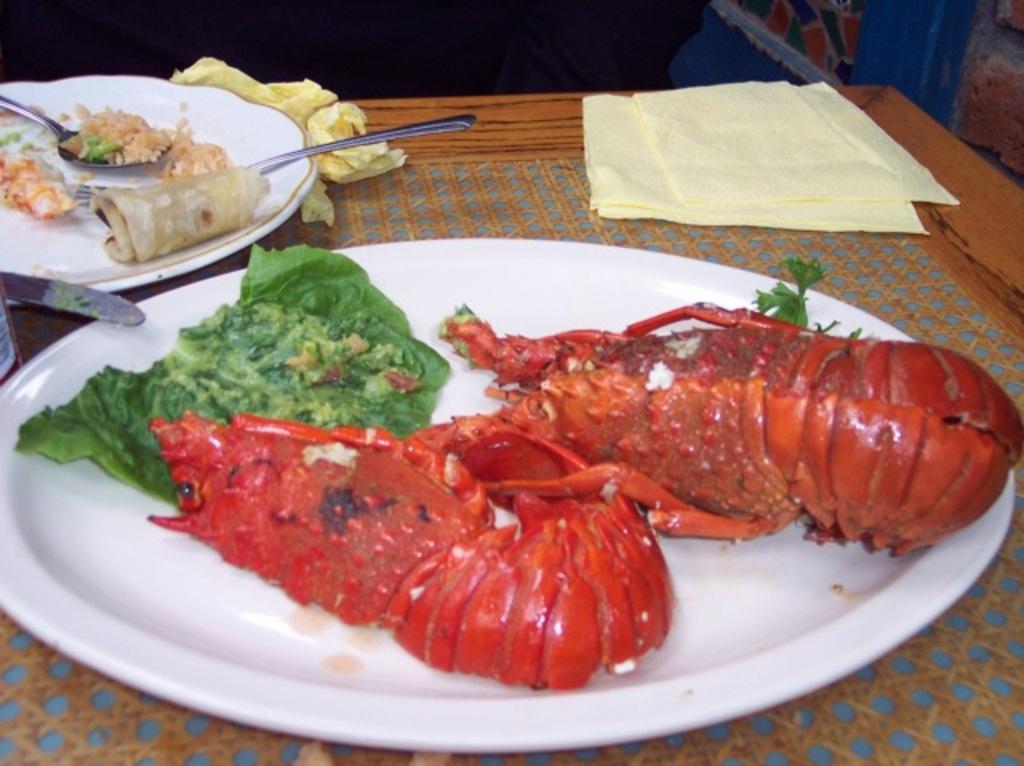Describe this image in one or two sentences. In this image there is a table and we can see plates, knife, fork, spoon, lobsters, napkins and some food placed on the table. 